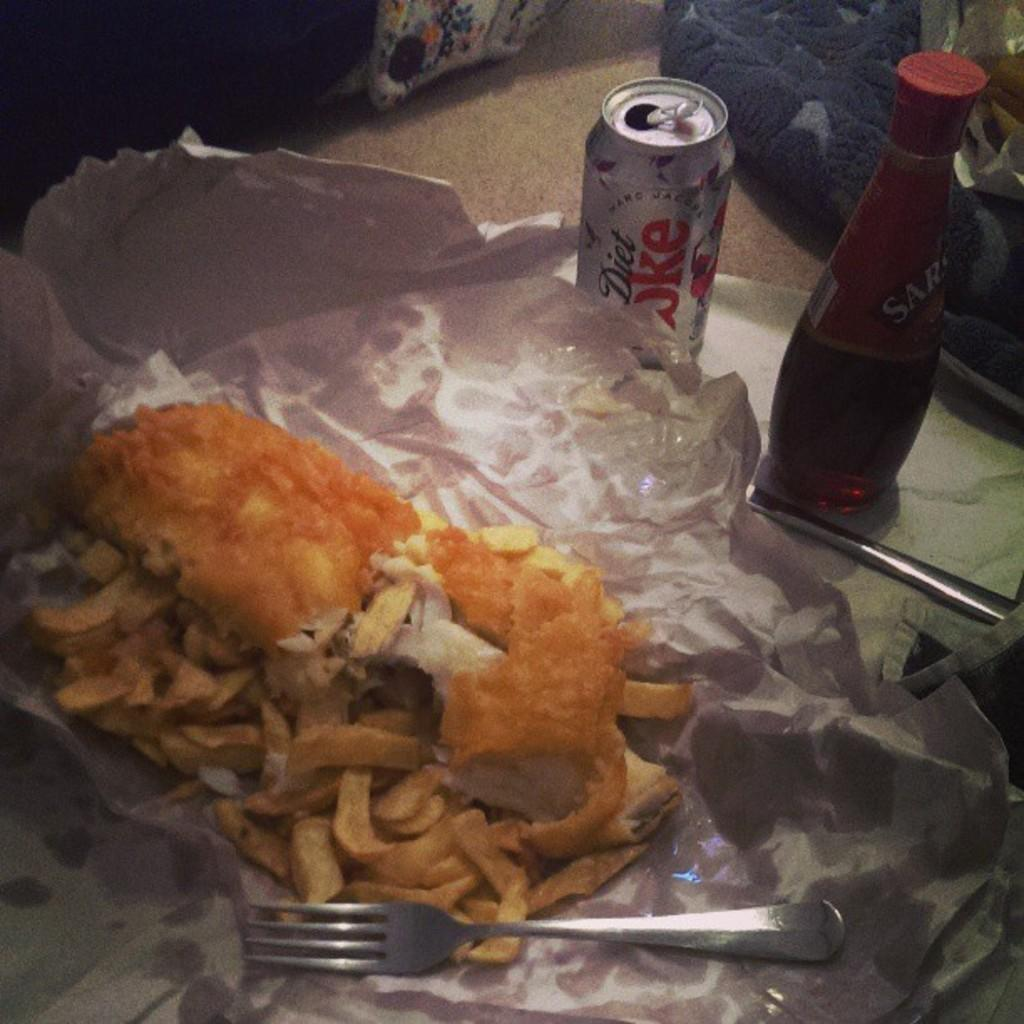What is on the paper in the image? There is food on a paper in the image. What utensil is present in the image? There is a fork in the image. What type of container is visible in the image? There is a bottle in the image. What type of beverage is in the tin can in the image? There is a tin can of diet coke in the image. What direction is the sailboat heading in the image? There is no sailboat present in the image. How many heads are visible in the image? There are no heads visible in the image. 